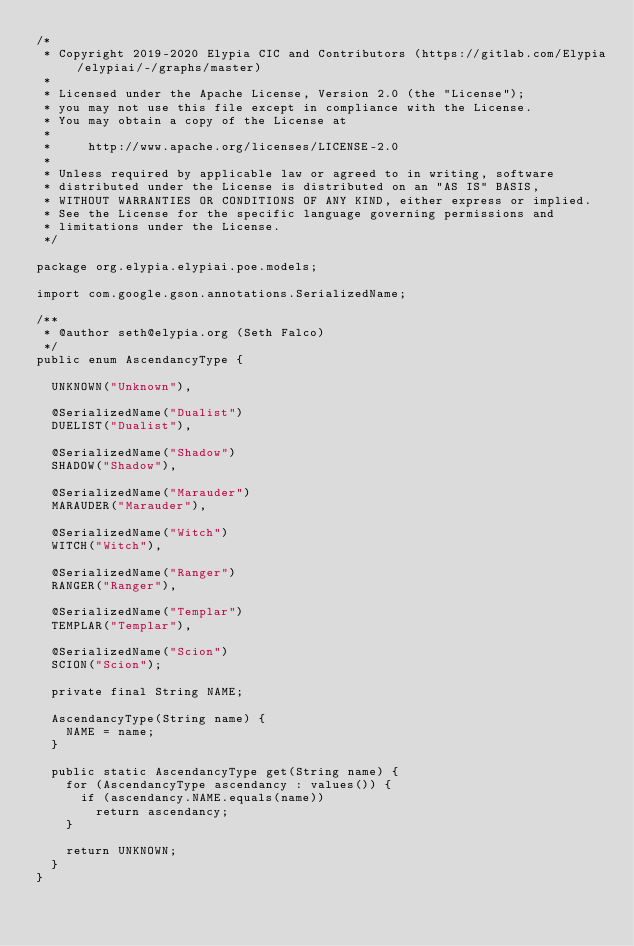Convert code to text. <code><loc_0><loc_0><loc_500><loc_500><_Java_>/*
 * Copyright 2019-2020 Elypia CIC and Contributors (https://gitlab.com/Elypia/elypiai/-/graphs/master)
 *
 * Licensed under the Apache License, Version 2.0 (the "License");
 * you may not use this file except in compliance with the License.
 * You may obtain a copy of the License at
 *
 *     http://www.apache.org/licenses/LICENSE-2.0
 *
 * Unless required by applicable law or agreed to in writing, software
 * distributed under the License is distributed on an "AS IS" BASIS,
 * WITHOUT WARRANTIES OR CONDITIONS OF ANY KIND, either express or implied.
 * See the License for the specific language governing permissions and
 * limitations under the License.
 */

package org.elypia.elypiai.poe.models;

import com.google.gson.annotations.SerializedName;

/**
 * @author seth@elypia.org (Seth Falco)
 */
public enum AscendancyType {

	UNKNOWN("Unknown"),

	@SerializedName("Dualist")
	DUELIST("Dualist"),

	@SerializedName("Shadow")
	SHADOW("Shadow"),

	@SerializedName("Marauder")
	MARAUDER("Marauder"),

	@SerializedName("Witch")
	WITCH("Witch"),

	@SerializedName("Ranger")
	RANGER("Ranger"),

	@SerializedName("Templar")
	TEMPLAR("Templar"),

	@SerializedName("Scion")
	SCION("Scion");

	private final String NAME;

	AscendancyType(String name) {
		NAME = name;
	}

	public static AscendancyType get(String name) {
		for (AscendancyType ascendancy : values()) {
			if (ascendancy.NAME.equals(name))
				return ascendancy;
		}

		return UNKNOWN;
	}
}
</code> 